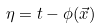<formula> <loc_0><loc_0><loc_500><loc_500>\eta = t - \phi ( \vec { x } )</formula> 